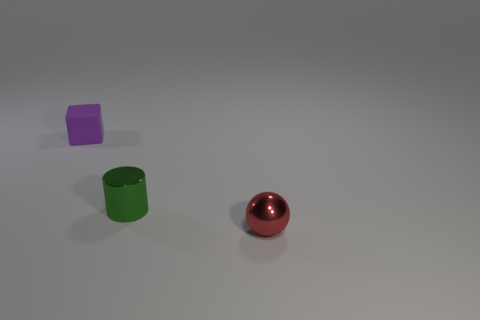Add 1 small metal objects. How many objects exist? 4 Subtract all balls. How many objects are left? 2 Subtract 0 yellow cubes. How many objects are left? 3 Subtract all tiny objects. Subtract all big green rubber cylinders. How many objects are left? 0 Add 1 tiny cubes. How many tiny cubes are left? 2 Add 3 green cylinders. How many green cylinders exist? 4 